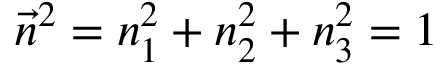<formula> <loc_0><loc_0><loc_500><loc_500>\vec { n } ^ { 2 } = n _ { 1 } ^ { 2 } + n _ { 2 } ^ { 2 } + n _ { 3 } ^ { 2 } = 1</formula> 